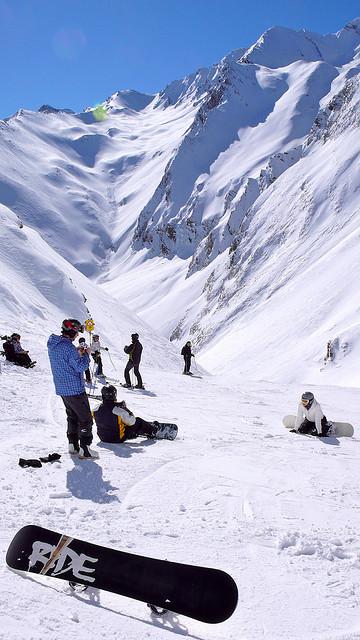What mountains are these?
Short answer required. Alps. How many men are there present?
Short answer required. 8. What is the brand name of the snowboard closest to the camera?
Be succinct. Ride. 